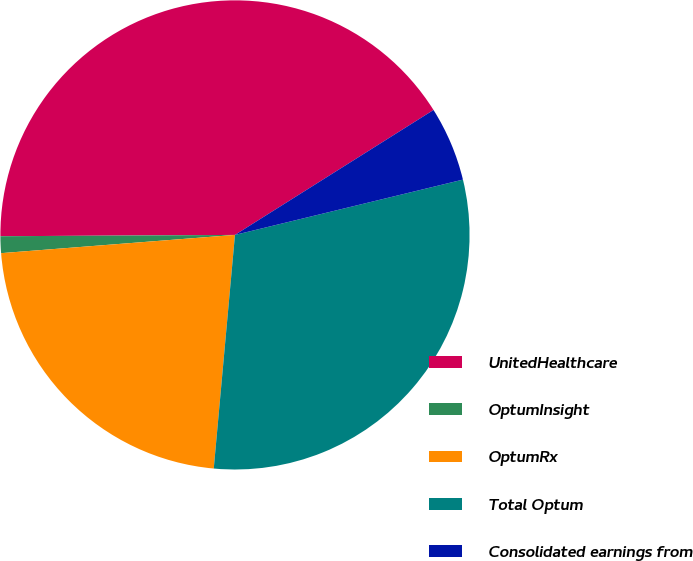Convert chart. <chart><loc_0><loc_0><loc_500><loc_500><pie_chart><fcel>UnitedHealthcare<fcel>OptumInsight<fcel>OptumRx<fcel>Total Optum<fcel>Consolidated earnings from<nl><fcel>41.15%<fcel>1.15%<fcel>22.32%<fcel>30.23%<fcel>5.15%<nl></chart> 